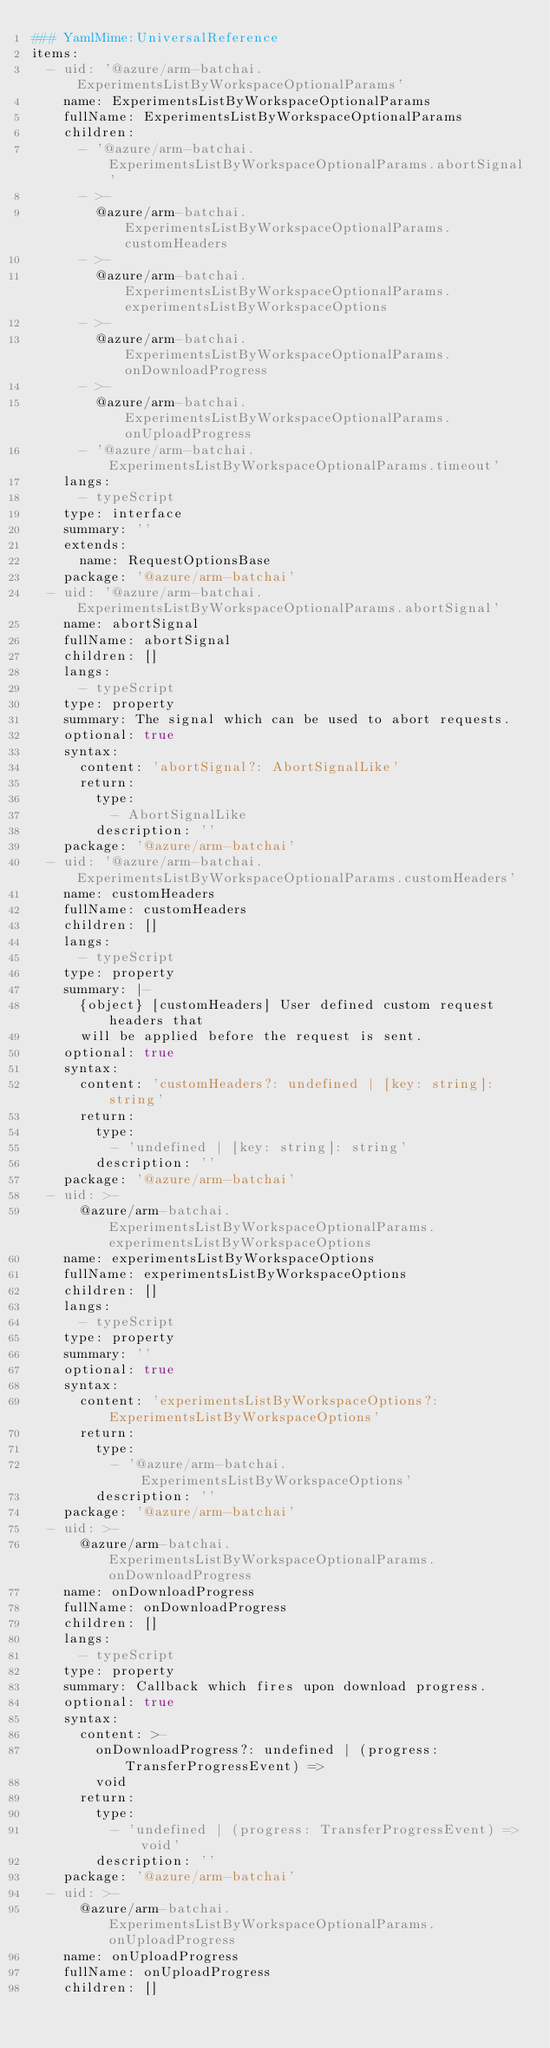Convert code to text. <code><loc_0><loc_0><loc_500><loc_500><_YAML_>### YamlMime:UniversalReference
items:
  - uid: '@azure/arm-batchai.ExperimentsListByWorkspaceOptionalParams'
    name: ExperimentsListByWorkspaceOptionalParams
    fullName: ExperimentsListByWorkspaceOptionalParams
    children:
      - '@azure/arm-batchai.ExperimentsListByWorkspaceOptionalParams.abortSignal'
      - >-
        @azure/arm-batchai.ExperimentsListByWorkspaceOptionalParams.customHeaders
      - >-
        @azure/arm-batchai.ExperimentsListByWorkspaceOptionalParams.experimentsListByWorkspaceOptions
      - >-
        @azure/arm-batchai.ExperimentsListByWorkspaceOptionalParams.onDownloadProgress
      - >-
        @azure/arm-batchai.ExperimentsListByWorkspaceOptionalParams.onUploadProgress
      - '@azure/arm-batchai.ExperimentsListByWorkspaceOptionalParams.timeout'
    langs:
      - typeScript
    type: interface
    summary: ''
    extends:
      name: RequestOptionsBase
    package: '@azure/arm-batchai'
  - uid: '@azure/arm-batchai.ExperimentsListByWorkspaceOptionalParams.abortSignal'
    name: abortSignal
    fullName: abortSignal
    children: []
    langs:
      - typeScript
    type: property
    summary: The signal which can be used to abort requests.
    optional: true
    syntax:
      content: 'abortSignal?: AbortSignalLike'
      return:
        type:
          - AbortSignalLike
        description: ''
    package: '@azure/arm-batchai'
  - uid: '@azure/arm-batchai.ExperimentsListByWorkspaceOptionalParams.customHeaders'
    name: customHeaders
    fullName: customHeaders
    children: []
    langs:
      - typeScript
    type: property
    summary: |-
      {object} [customHeaders] User defined custom request headers that
      will be applied before the request is sent.
    optional: true
    syntax:
      content: 'customHeaders?: undefined | [key: string]: string'
      return:
        type:
          - 'undefined | [key: string]: string'
        description: ''
    package: '@azure/arm-batchai'
  - uid: >-
      @azure/arm-batchai.ExperimentsListByWorkspaceOptionalParams.experimentsListByWorkspaceOptions
    name: experimentsListByWorkspaceOptions
    fullName: experimentsListByWorkspaceOptions
    children: []
    langs:
      - typeScript
    type: property
    summary: ''
    optional: true
    syntax:
      content: 'experimentsListByWorkspaceOptions?: ExperimentsListByWorkspaceOptions'
      return:
        type:
          - '@azure/arm-batchai.ExperimentsListByWorkspaceOptions'
        description: ''
    package: '@azure/arm-batchai'
  - uid: >-
      @azure/arm-batchai.ExperimentsListByWorkspaceOptionalParams.onDownloadProgress
    name: onDownloadProgress
    fullName: onDownloadProgress
    children: []
    langs:
      - typeScript
    type: property
    summary: Callback which fires upon download progress.
    optional: true
    syntax:
      content: >-
        onDownloadProgress?: undefined | (progress: TransferProgressEvent) =>
        void
      return:
        type:
          - 'undefined | (progress: TransferProgressEvent) => void'
        description: ''
    package: '@azure/arm-batchai'
  - uid: >-
      @azure/arm-batchai.ExperimentsListByWorkspaceOptionalParams.onUploadProgress
    name: onUploadProgress
    fullName: onUploadProgress
    children: []</code> 